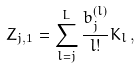Convert formula to latex. <formula><loc_0><loc_0><loc_500><loc_500>Z _ { j , 1 } = \sum _ { l = j } ^ { L } \frac { b ^ { ( l ) } _ { j } } { l ! } K _ { l } \, ,</formula> 